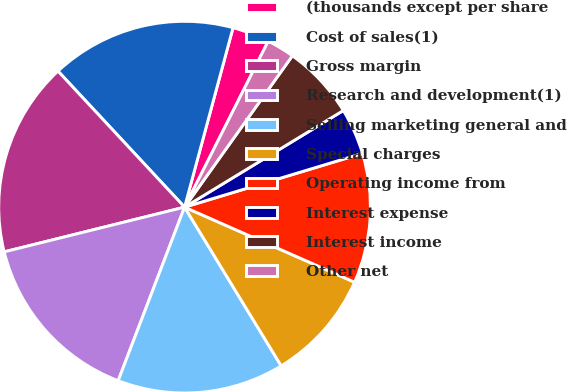Convert chart. <chart><loc_0><loc_0><loc_500><loc_500><pie_chart><fcel>(thousands except per share<fcel>Cost of sales(1)<fcel>Gross margin<fcel>Research and development(1)<fcel>Selling marketing general and<fcel>Special charges<fcel>Operating income from<fcel>Interest expense<fcel>Interest income<fcel>Other net<nl><fcel>3.23%<fcel>16.13%<fcel>16.94%<fcel>15.32%<fcel>14.52%<fcel>9.68%<fcel>11.29%<fcel>4.03%<fcel>6.45%<fcel>2.42%<nl></chart> 